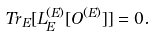<formula> <loc_0><loc_0><loc_500><loc_500>T r _ { E } [ L _ { E } ^ { ( E ) } [ O ^ { ( E ) } ] ] = 0 .</formula> 